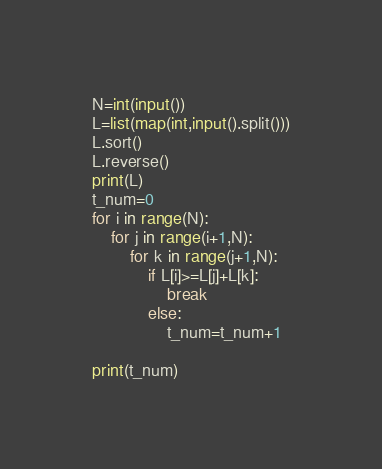Convert code to text. <code><loc_0><loc_0><loc_500><loc_500><_Python_>N=int(input())
L=list(map(int,input().split()))
L.sort()
L.reverse()
print(L)
t_num=0
for i in range(N):
    for j in range(i+1,N):
        for k in range(j+1,N):
            if L[i]>=L[j]+L[k]:
                break
            else:
                t_num=t_num+1
                
print(t_num)</code> 